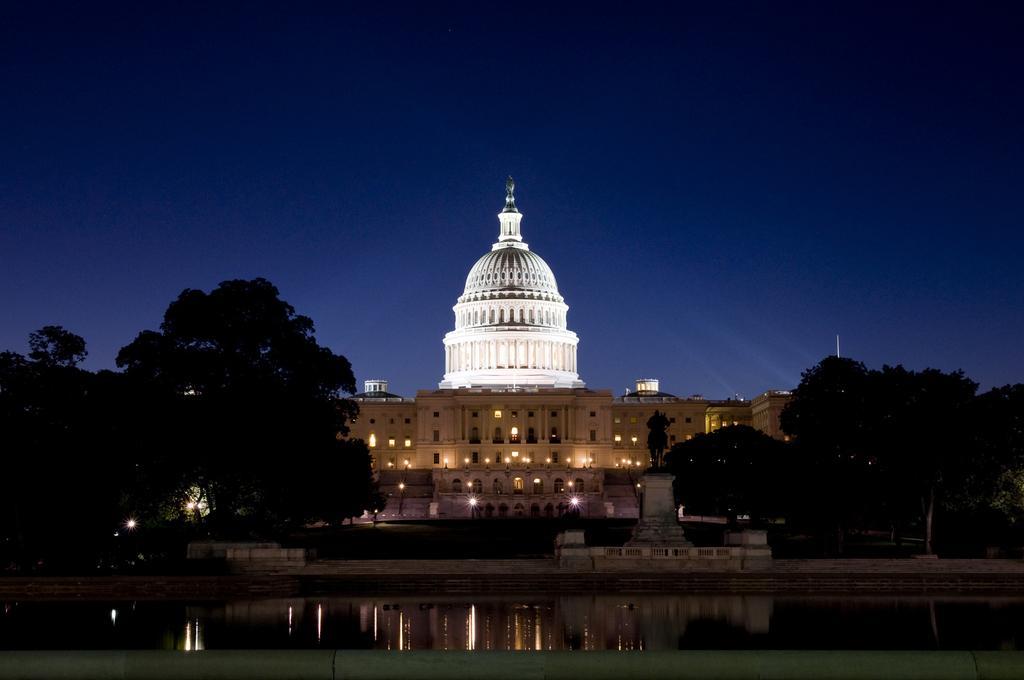Could you give a brief overview of what you see in this image? In this picture there is a building. At the top of the building there is a dome. In the center there is a statue of a person and horse which is kept on the stone. At the bottom there is a water. On the right and left side i can see trees and plants. On the building i can see many lights. At the top there is a sky. 